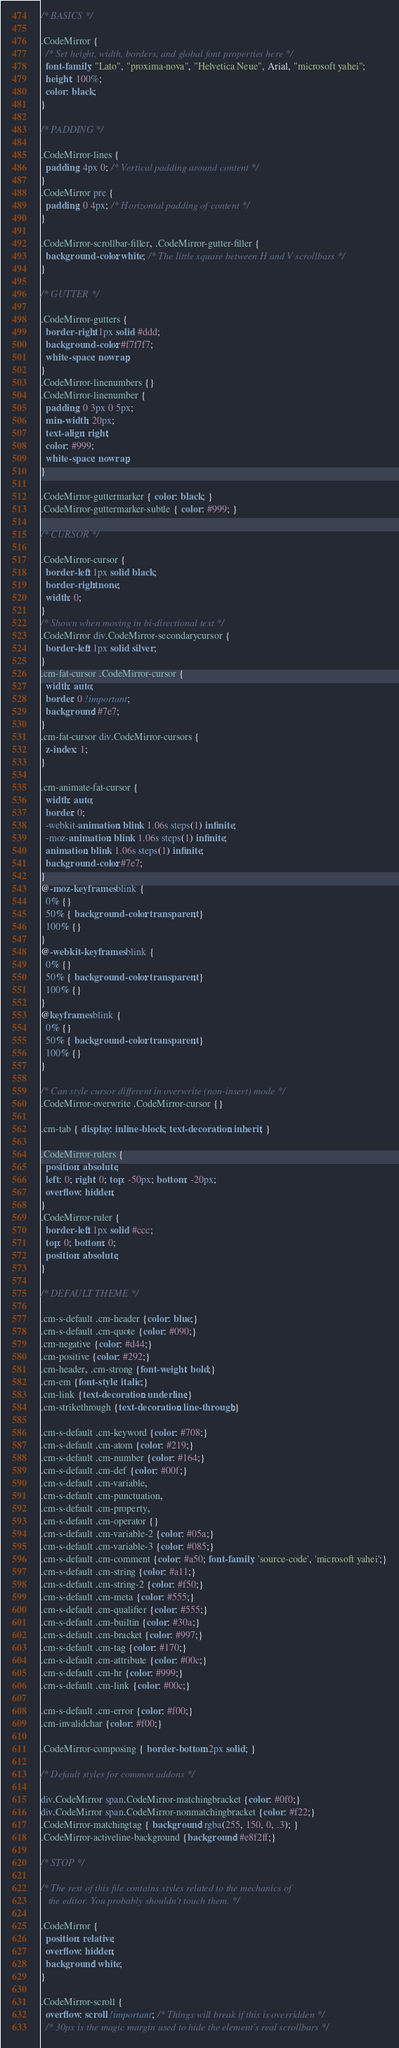Convert code to text. <code><loc_0><loc_0><loc_500><loc_500><_CSS_>/* BASICS */

.CodeMirror {
  /* Set height, width, borders, and global font properties here */
  font-family: "Lato", "proxima-nova", "Helvetica Neue", Arial, "microsoft yahei";
  height: 100%;
  color: black;
}

/* PADDING */

.CodeMirror-lines {
  padding: 4px 0; /* Vertical padding around content */
}
.CodeMirror pre {
  padding: 0 4px; /* Horizontal padding of content */
}

.CodeMirror-scrollbar-filler, .CodeMirror-gutter-filler {
  background-color: white; /* The little square between H and V scrollbars */
}

/* GUTTER */

.CodeMirror-gutters {
  border-right: 1px solid #ddd;
  background-color: #f7f7f7;
  white-space: nowrap;
}
.CodeMirror-linenumbers {}
.CodeMirror-linenumber {
  padding: 0 3px 0 5px;
  min-width: 20px;
  text-align: right;
  color: #999;
  white-space: nowrap;
}

.CodeMirror-guttermarker { color: black; }
.CodeMirror-guttermarker-subtle { color: #999; }

/* CURSOR */

.CodeMirror-cursor {
  border-left: 1px solid black;
  border-right: none;
  width: 0;
}
/* Shown when moving in bi-directional text */
.CodeMirror div.CodeMirror-secondarycursor {
  border-left: 1px solid silver;
}
.cm-fat-cursor .CodeMirror-cursor {
  width: auto;
  border: 0 !important;
  background: #7e7;
}
.cm-fat-cursor div.CodeMirror-cursors {
  z-index: 1;
}

.cm-animate-fat-cursor {
  width: auto;
  border: 0;
  -webkit-animation: blink 1.06s steps(1) infinite;
  -moz-animation: blink 1.06s steps(1) infinite;
  animation: blink 1.06s steps(1) infinite;
  background-color: #7e7;
}
@-moz-keyframes blink {
  0% {}
  50% { background-color: transparent; }
  100% {}
}
@-webkit-keyframes blink {
  0% {}
  50% { background-color: transparent; }
  100% {}
}
@keyframes blink {
  0% {}
  50% { background-color: transparent; }
  100% {}
}

/* Can style cursor different in overwrite (non-insert) mode */
.CodeMirror-overwrite .CodeMirror-cursor {}

.cm-tab { display: inline-block; text-decoration: inherit; }

.CodeMirror-rulers {
  position: absolute;
  left: 0; right: 0; top: -50px; bottom: -20px;
  overflow: hidden;
}
.CodeMirror-ruler {
  border-left: 1px solid #ccc;
  top: 0; bottom: 0;
  position: absolute;
}

/* DEFAULT THEME */

.cm-s-default .cm-header {color: blue;}
.cm-s-default .cm-quote {color: #090;}
.cm-negative {color: #d44;}
.cm-positive {color: #292;}
.cm-header, .cm-strong {font-weight: bold;}
.cm-em {font-style: italic;}
.cm-link {text-decoration: underline;}
.cm-strikethrough {text-decoration: line-through;}

.cm-s-default .cm-keyword {color: #708;}
.cm-s-default .cm-atom {color: #219;}
.cm-s-default .cm-number {color: #164;}
.cm-s-default .cm-def {color: #00f;}
.cm-s-default .cm-variable,
.cm-s-default .cm-punctuation,
.cm-s-default .cm-property,
.cm-s-default .cm-operator {}
.cm-s-default .cm-variable-2 {color: #05a;}
.cm-s-default .cm-variable-3 {color: #085;}
.cm-s-default .cm-comment {color: #a50; font-family: 'source-code', 'microsoft yahei';}
.cm-s-default .cm-string {color: #a11;}
.cm-s-default .cm-string-2 {color: #f50;}
.cm-s-default .cm-meta {color: #555;}
.cm-s-default .cm-qualifier {color: #555;}
.cm-s-default .cm-builtin {color: #30a;}
.cm-s-default .cm-bracket {color: #997;}
.cm-s-default .cm-tag {color: #170;}
.cm-s-default .cm-attribute {color: #00c;}
.cm-s-default .cm-hr {color: #999;}
.cm-s-default .cm-link {color: #00c;}

.cm-s-default .cm-error {color: #f00;}
.cm-invalidchar {color: #f00;}

.CodeMirror-composing { border-bottom: 2px solid; }

/* Default styles for common addons */

div.CodeMirror span.CodeMirror-matchingbracket {color: #0f0;}
div.CodeMirror span.CodeMirror-nonmatchingbracket {color: #f22;}
.CodeMirror-matchingtag { background: rgba(255, 150, 0, .3); }
.CodeMirror-activeline-background {background: #e8f2ff;}

/* STOP */

/* The rest of this file contains styles related to the mechanics of
   the editor. You probably shouldn't touch them. */

.CodeMirror {
  position: relative;
  overflow: hidden;
  background: white;
}

.CodeMirror-scroll {
  overflow: scroll !important; /* Things will break if this is overridden */
  /* 30px is the magic margin used to hide the element's real scrollbars */</code> 